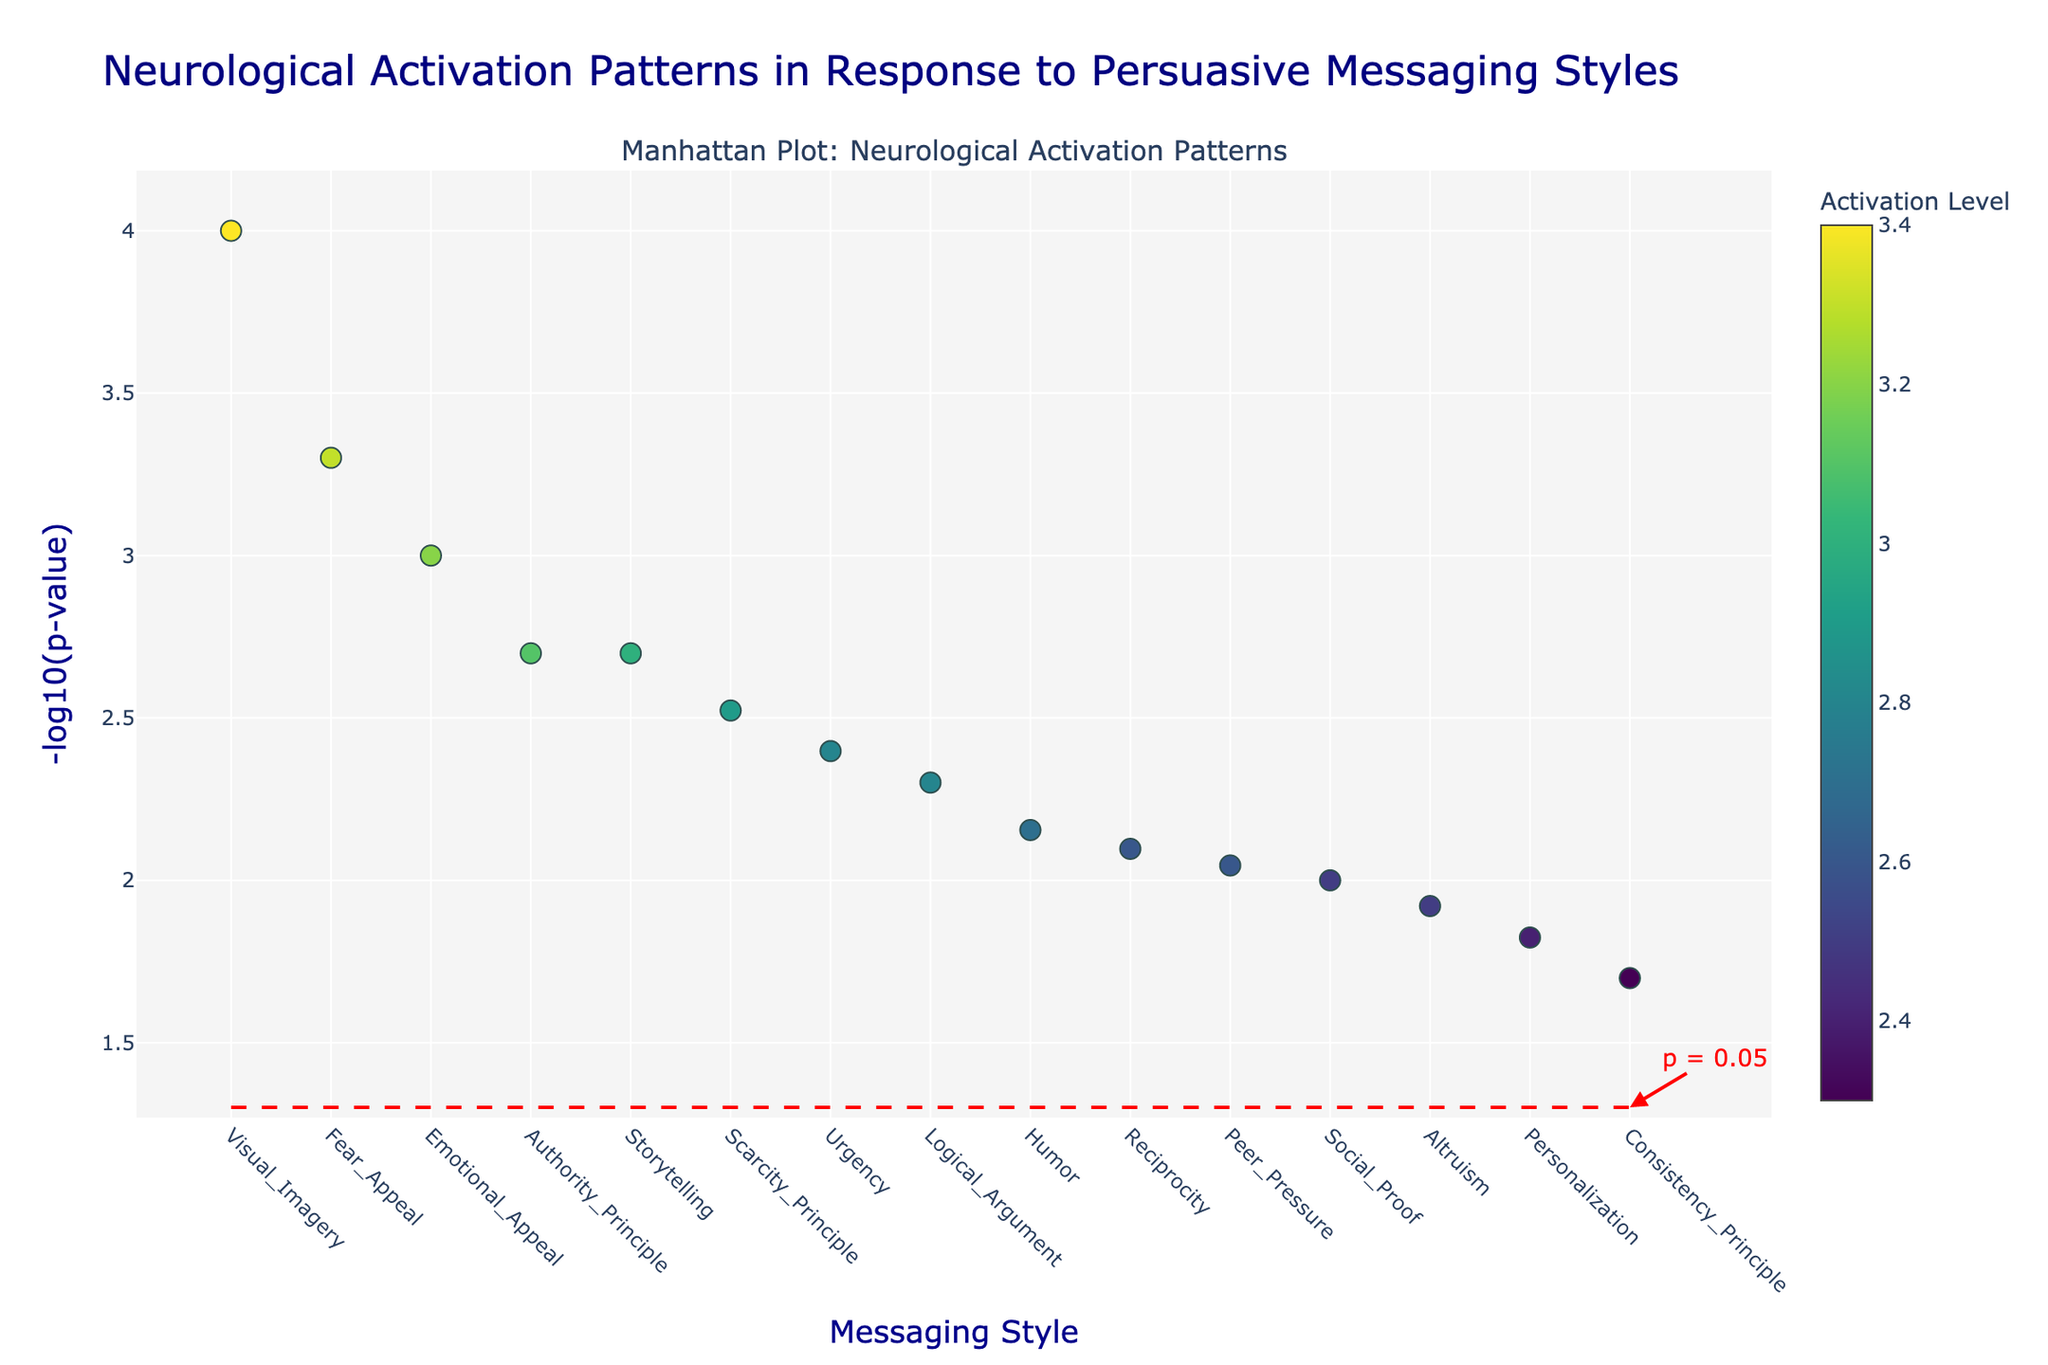What is the title of the figure? The title of the figure is located at the top of the plot and describes the main focus of the analysis. Reading the text at the top reveals the title of the plot.
Answer: Neurological Activation Patterns in Response to Persuasive Messaging Styles How many data points (unique messaging styles) are shown in the figure? Each data point is represented by a distinct marker along the x-axis, corresponding to different messaging styles. By counting these markers, we determine the total number.
Answer: 15 Which messaging style shows the most statistically significant activation? Statistical significance is represented by the y-axis value -log10(p-value). The higher this value, the more significant it is. Locate the highest point on the y-axis to find the corresponding messaging style.
Answer: Visual Imagery What is the significance threshold marked on the plot? The significance threshold is indicated by the red dashed line across the plot. The annotation near the line specifies the p-value at which this threshold is set. Convert -log10(p-value) into p-value itself.
Answer: 0.05 How does the activation level of the Emotional Appeal messaging style compare to the Logical Argument style? Locate both messaging styles on the x-axis and compare the corresponding marker colors, which denote activation levels using the color bar. Emotional Appeal is shown in the Amygdala with an activation of 3.2, while Logical Argument is in the Prefrontal Cortex with an activation of 2.8. Compare these values directly.
Answer: Emotional Appeal is higher Which brain region is most associated with the Fear Appeal messaging style based on activation level? Identify the Fear Appeal marker on the x-axis. The hover text or tooltip will show the specific brain region associated with Fear Appeal, revealing the highest activation level recorded.
Answer: Hypothalamus Among Reciprocity, Personalization, and Authority Principle, which messaging style has the lowest significance? Locate these three messaging styles on the x-axis. Compare their y-axis values representing -log10(p-value). The lowest y-axis value corresponds to the least significant result.
Answer: Personalization What is the average significance value (-log10(p-value)) of all messaging styles? To calculate the average, sum up all y-axis values for each messaging style and divide by the number of data points (15). For example, adding the -log10(p-values) of each data point and then dividing by the total number of styles.
Answer: (3.38 + 3.30 + ... + 2.32) / 15 = approximately 2.79 Which brain region shows activation for the Scarcity Principle messaging style, and how statistically significant is it based on the plot? Locate the Scarcity Principle marker and refer to the hover text or check the coordinates. Identify the brain region and read off its -log10(p-value) from the y-axis.
Answer: Nucleus Accumbens, -log10(p-value) is approximately 2.52 How does the activation level of Peer Pressure compare to that of Storytelling? Locate both messaging styles on the x-axis and compare their respective marker colors. Check the color bar for specific activation level values for each style.
Answer: Peer Pressure is lower than Storytelling 